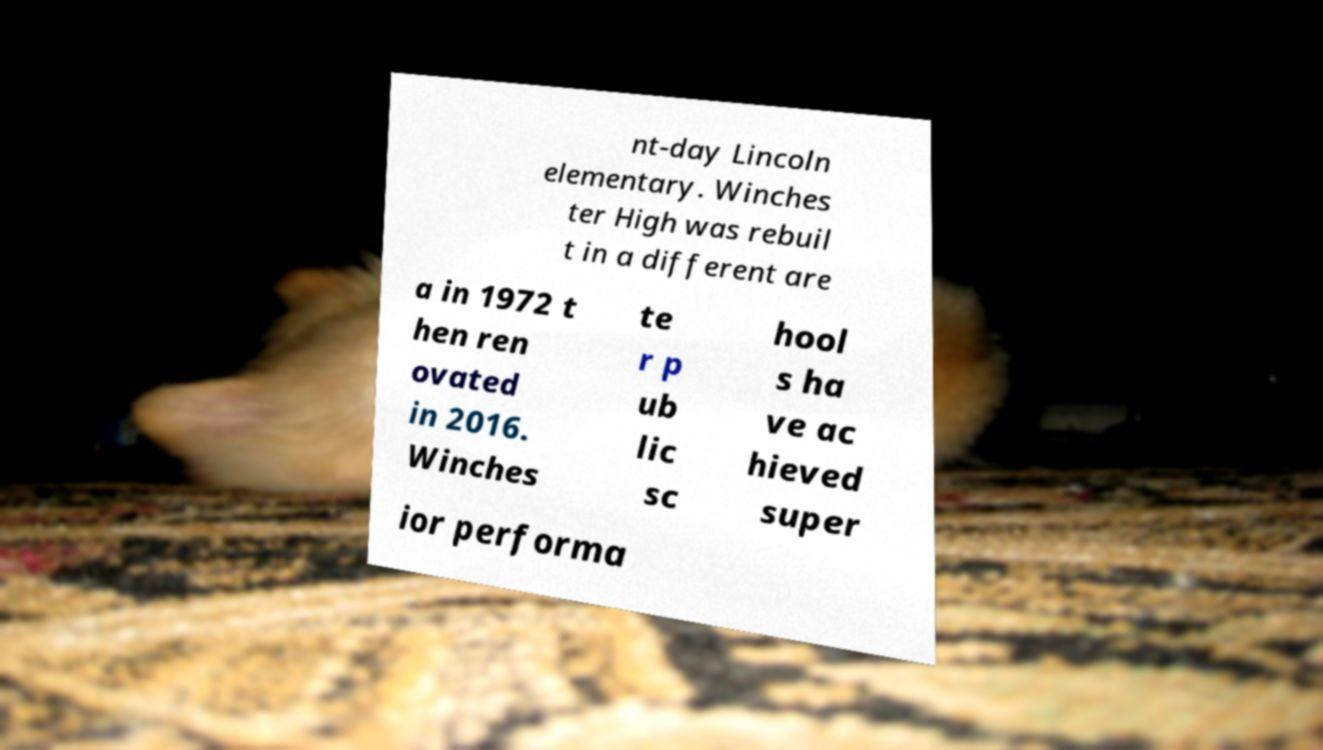Please identify and transcribe the text found in this image. nt-day Lincoln elementary. Winches ter High was rebuil t in a different are a in 1972 t hen ren ovated in 2016. Winches te r p ub lic sc hool s ha ve ac hieved super ior performa 